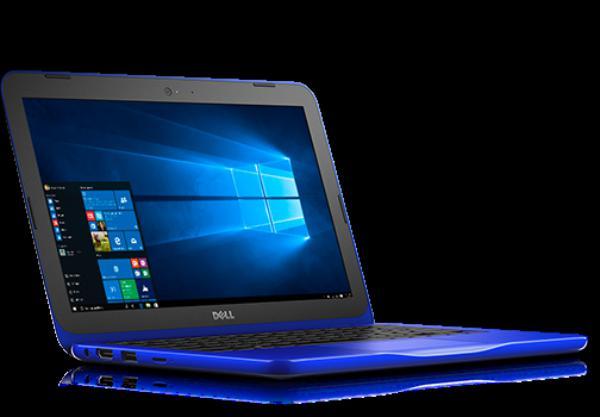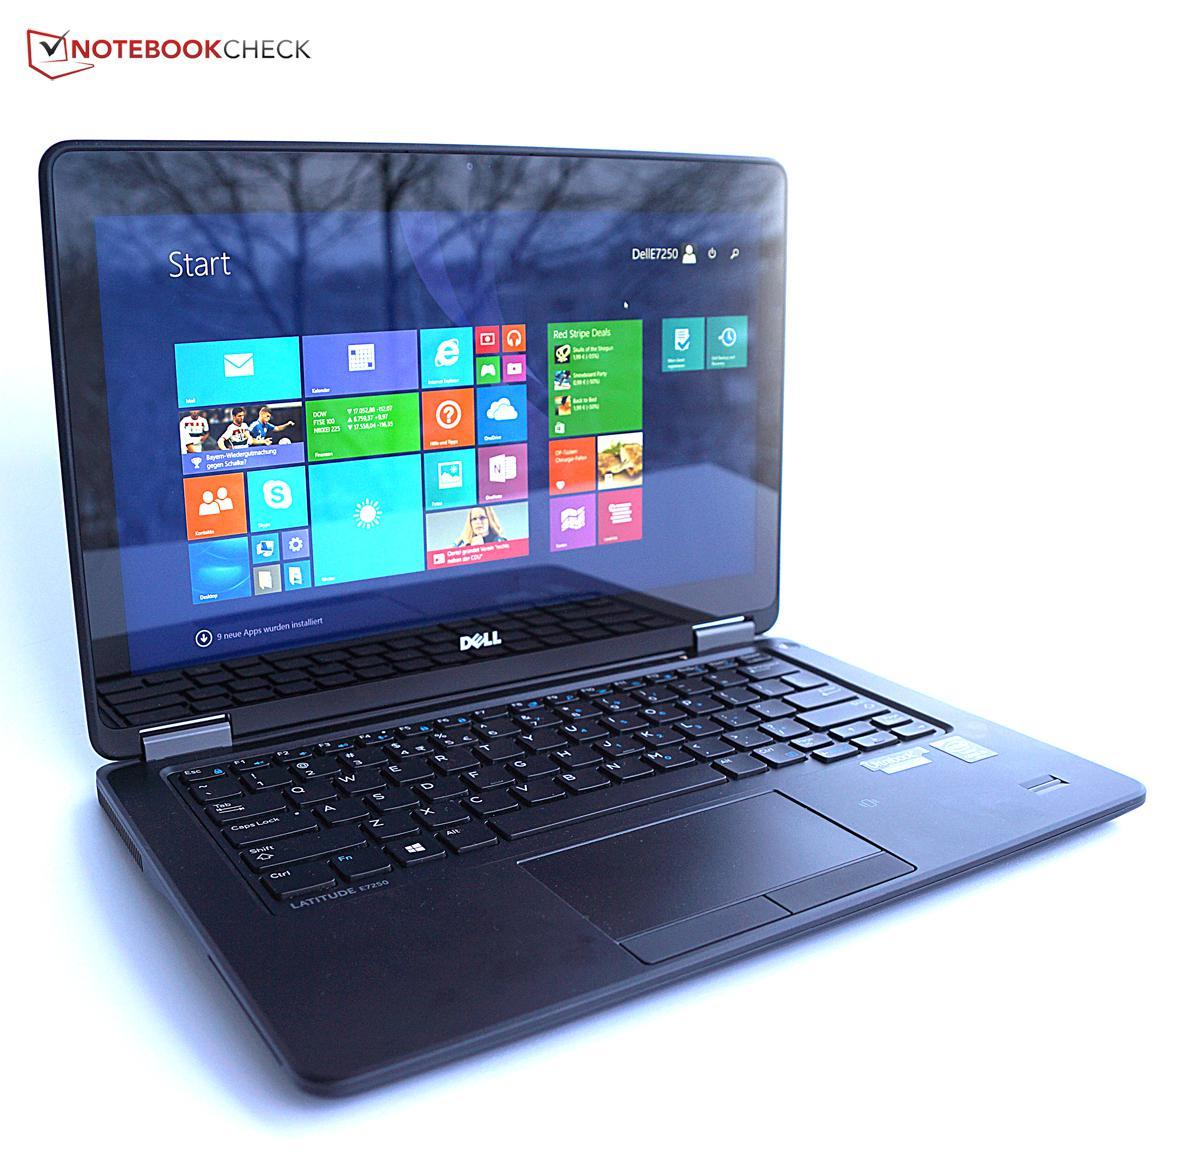The first image is the image on the left, the second image is the image on the right. Examine the images to the left and right. Is the description "One of the images shows an open laptop viewed head-on, with a screen displaying a blue background." accurate? Answer yes or no. No. The first image is the image on the left, the second image is the image on the right. Analyze the images presented: Is the assertion "One of the laptops has wallpaper that looks like light shining through a window." valid? Answer yes or no. Yes. 